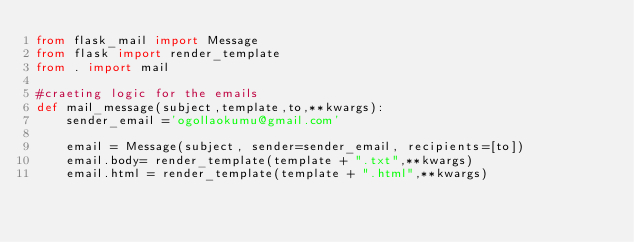Convert code to text. <code><loc_0><loc_0><loc_500><loc_500><_Python_>from flask_mail import Message
from flask import render_template
from . import mail

#craeting logic for the emails
def mail_message(subject,template,to,**kwargs):
    sender_email ='ogollaokumu@gmail.com'

    email = Message(subject, sender=sender_email, recipients=[to])
    email.body= render_template(template + ".txt",**kwargs)
    email.html = render_template(template + ".html",**kwargs)
</code> 